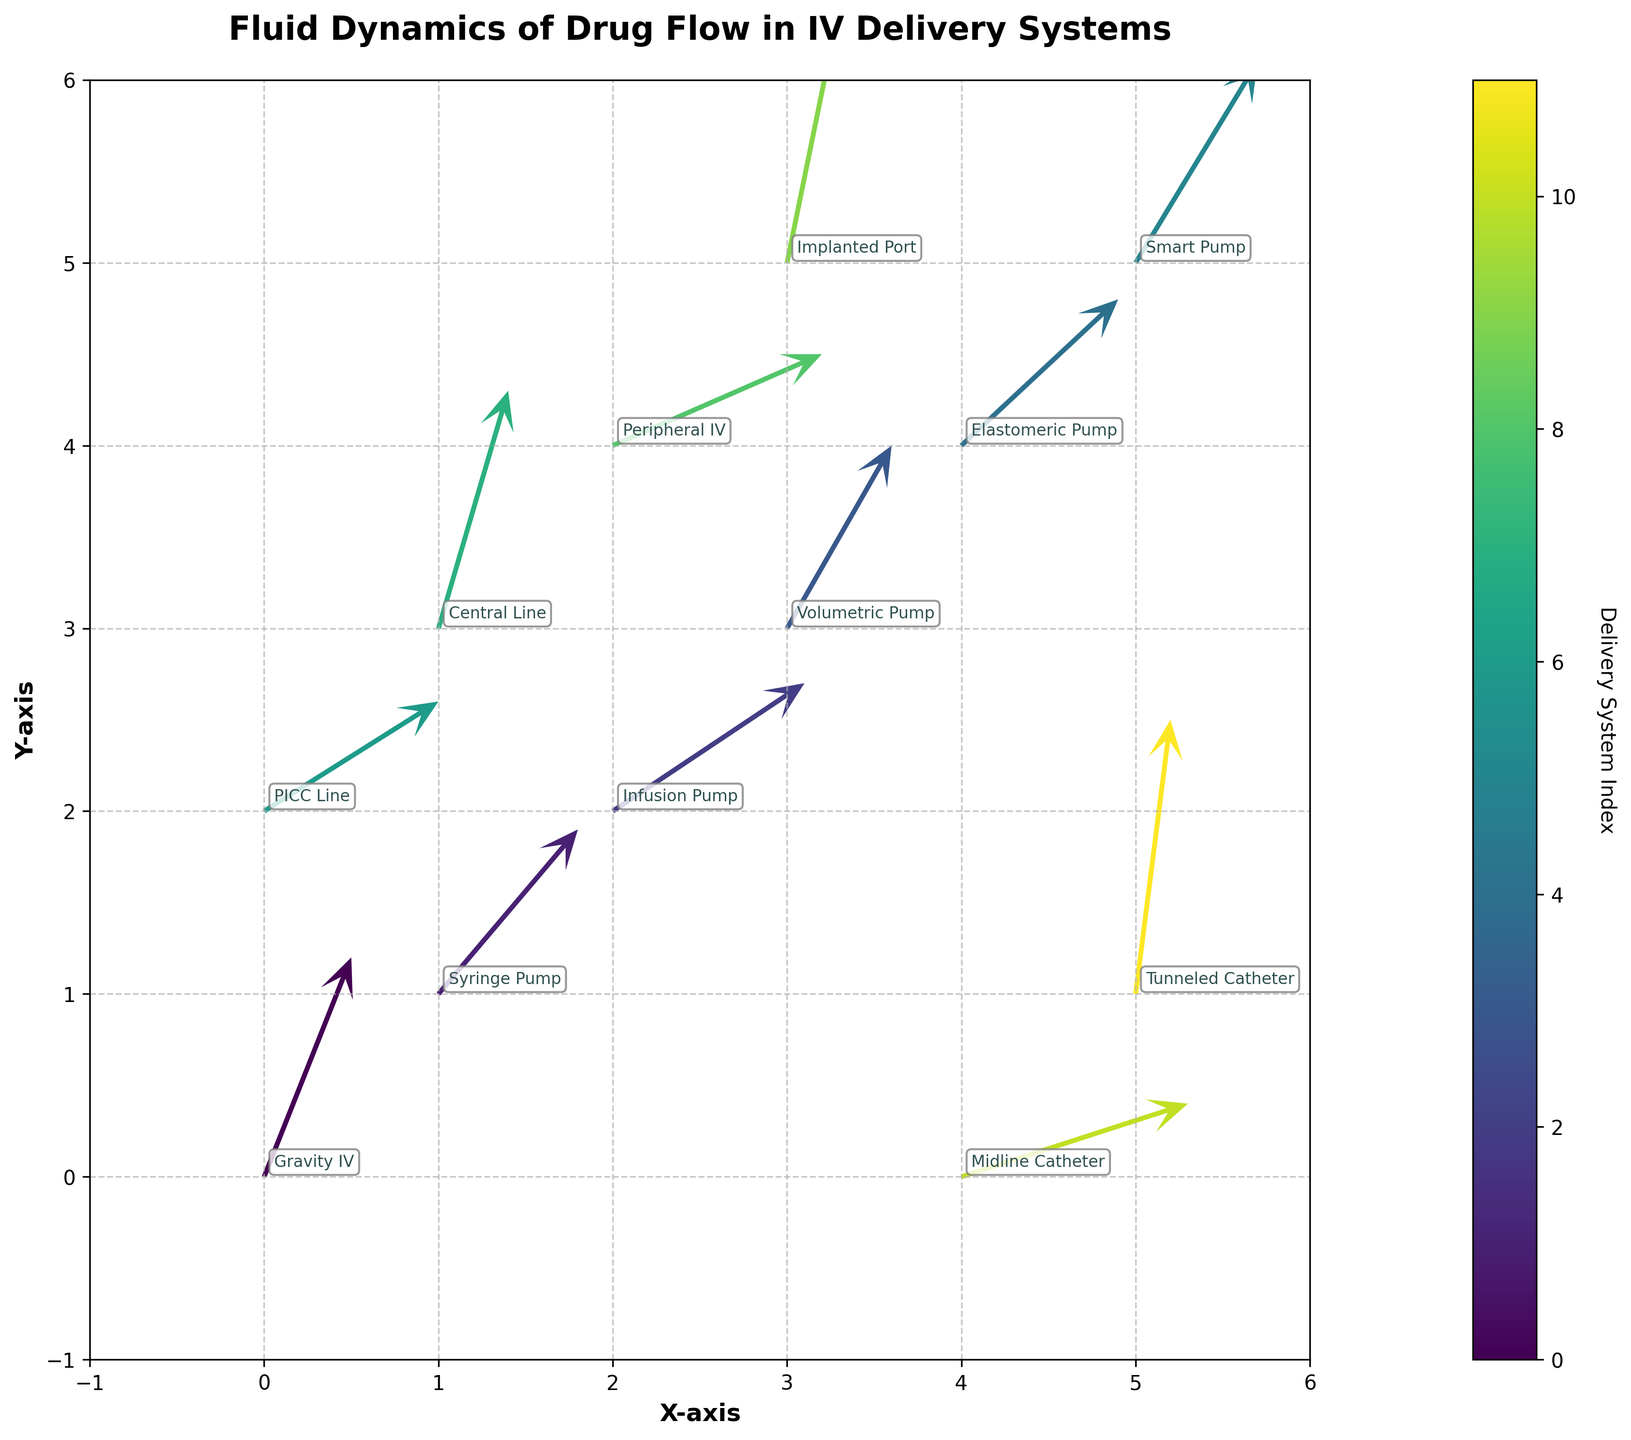How many intravenous delivery systems are shown in the figure? Count the distinct labels in the annotations for each system.
Answer: 12 Which intravenous delivery system has the highest vector magnitude? Calculate the vector magnitude for each system using the formula √(u² + v²) and compare them. The magnitude for the Tunneled Catheter is the highest: √(0.2² + 1.5²) = 1.513.
Answer: Tunneled Catheter What are the x and y axes labeled, and what are their ranges? The x-axis is labeled "X-axis" and the y-axis is labeled "Y-axis." Both axes range from -1 to 6.
Answer: X-axis: -1 to 6, Y-axis: -1 to 6 Which delivery system has the smallest horizontal component (u-value) of fluid flow? Identify the smallest u-value among all systems. The smallest u-value is 0.2, which corresponds to the Tunneled Catheter.
Answer: Tunneled Catheter How does the angle of the vector for the Central Line compare to the angle for the Peripheral IV? Calculate the angles using the arctan(v/u) formula for both systems. Central Line's vector angle = arctan(1.3/0.4) and Peripheral IV's vector angle = arctan(0.5/1.2). Compare the angles to see which is greater. Central Line has a steeper angle compared to Peripheral IV.
Answer: Central Line is steeper What is the color scheme used in the plot to represent different systems, and what does the color bar indicate? The color scheme is a gradient from the Viridis colormap. The color bar indicates the delivery system index, ranging from 0 to 11.
Answer: Viridis colormap, indexes 0 to 11 Can you identify which systems have their arrows pointing primarily upwards? By examining the v-values (vertical components), determine the systems with positive v values and additionally check their u values for less influence. Arrows for Gravity IV, Smart Pump, and Implanted Port point primarily upwards.
Answer: Gravity IV, Smart Pump, Implanted Port How does the flow direction of the Elastomeric Pump compare to the flow direction of the Infusion Pump? Compare the (u, v) components of both systems. Elastomeric Pump has (0.9, 0.8) and Infusion Pump has (1.1, 0.7). The Elastomeric Pump has a slightly more balanced u and v direction compared to Infusion Pump which has more horizontal direction.
Answer: Elastomeric Pump is more balanced Between the PICC Line and Midline Catheter, which has a greater contribution from the horizontal component of flow? Compare the u values for PICC Line (1.0) and Midline Catheter (1.3). Midline Catheter's u value is greater.
Answer: Midline Catheter What delivery system has the coordinates (4, 0) and what are its u and v values? Identify the system from the coordinates and read off its u and v values. The system at (4, 0) is the Midline Catheter with u = 1.3 and v = 0.4.
Answer: Midline Catheter, u = 1.3, v = 0.4 